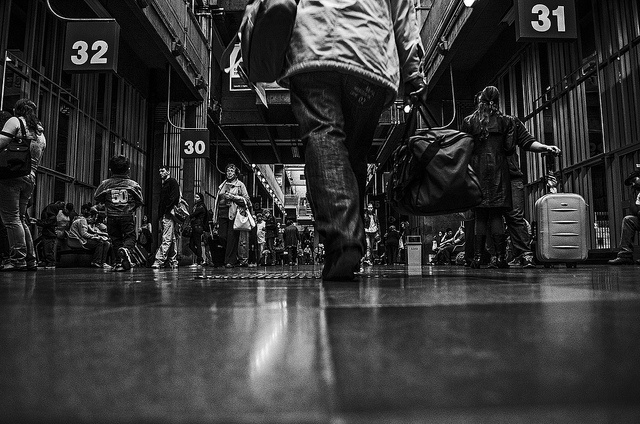Describe the objects in this image and their specific colors. I can see people in black, darkgray, gray, and lightgray tones, handbag in black, gray, darkgray, and lightgray tones, people in black, gray, darkgray, and lightgray tones, people in black, gray, darkgray, and lightgray tones, and handbag in black, gray, darkgray, and lightgray tones in this image. 